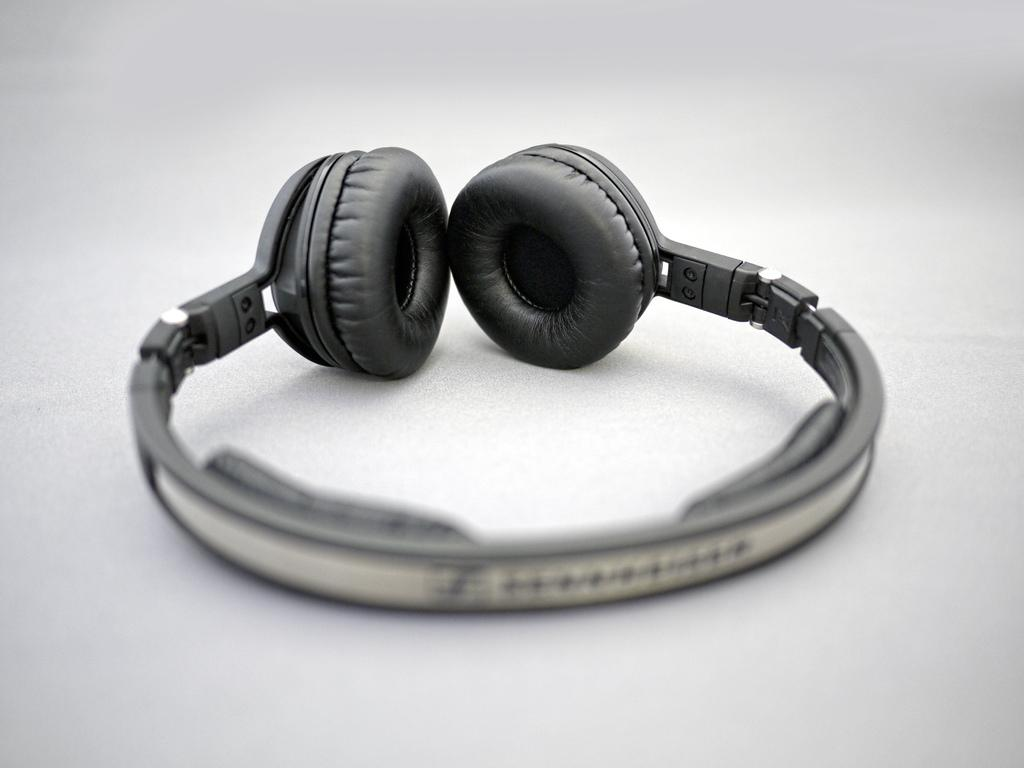What is the main object in the image? There is a headset in the image. Can you describe the headset in more detail? The headset appears to have earpieces and a microphone, which are common features of headsets used for communication or audio purposes. How does the headset contribute to the transportation of goods in the image? The headset does not contribute to the transportation of goods in the image, as it is an audio device and not related to transportation. 